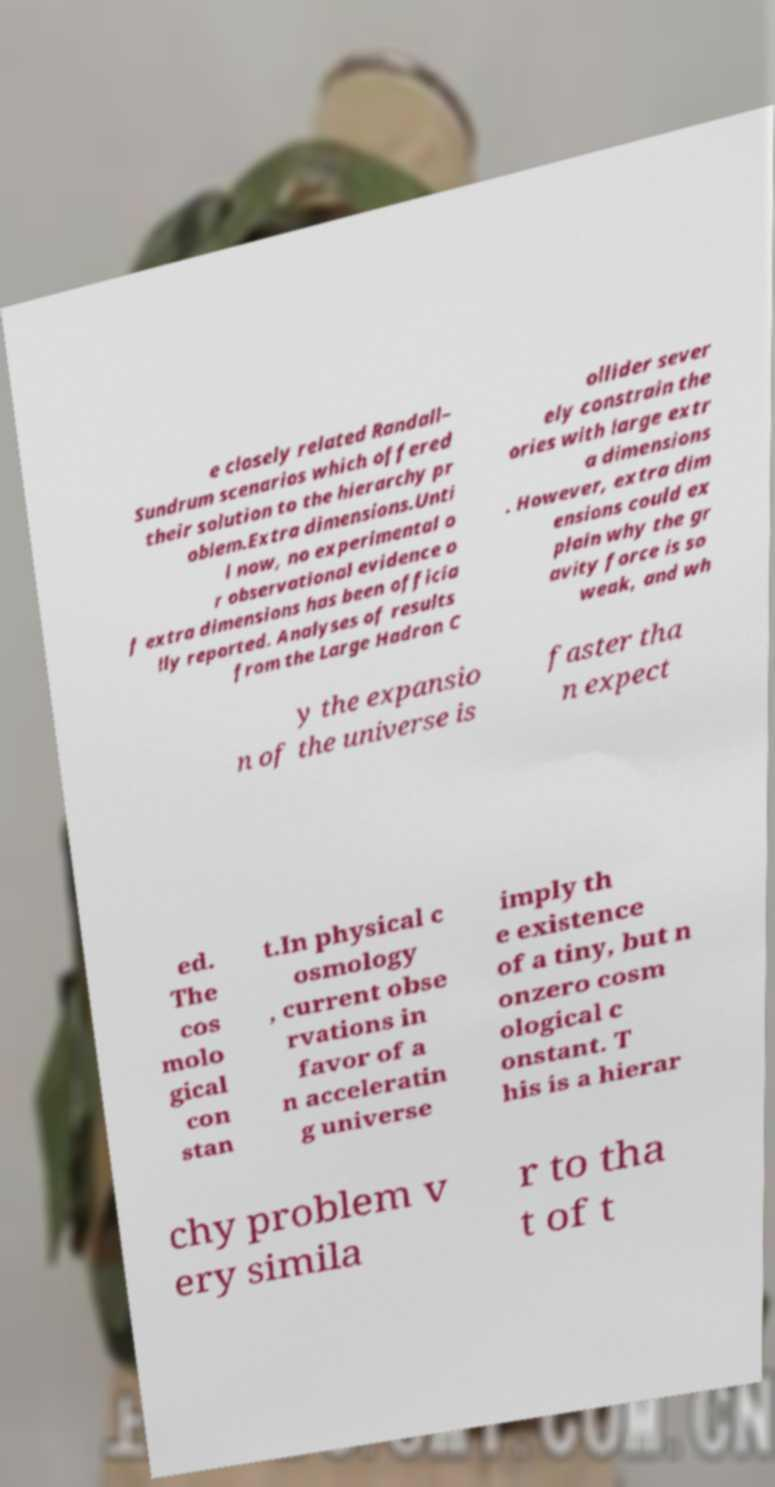What messages or text are displayed in this image? I need them in a readable, typed format. e closely related Randall– Sundrum scenarios which offered their solution to the hierarchy pr oblem.Extra dimensions.Unti l now, no experimental o r observational evidence o f extra dimensions has been officia lly reported. Analyses of results from the Large Hadron C ollider sever ely constrain the ories with large extr a dimensions . However, extra dim ensions could ex plain why the gr avity force is so weak, and wh y the expansio n of the universe is faster tha n expect ed. The cos molo gical con stan t.In physical c osmology , current obse rvations in favor of a n acceleratin g universe imply th e existence of a tiny, but n onzero cosm ological c onstant. T his is a hierar chy problem v ery simila r to tha t of t 